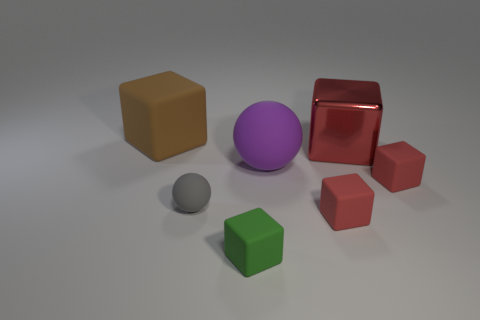Subtract all yellow balls. How many red blocks are left? 3 Subtract 2 cubes. How many cubes are left? 3 Subtract all green cubes. How many cubes are left? 4 Subtract all big shiny blocks. How many blocks are left? 4 Subtract all gray blocks. Subtract all brown balls. How many blocks are left? 5 Add 2 small matte spheres. How many objects exist? 9 Subtract all cubes. How many objects are left? 2 Add 1 red metallic blocks. How many red metallic blocks exist? 2 Subtract 0 red balls. How many objects are left? 7 Subtract all gray rubber blocks. Subtract all small green cubes. How many objects are left? 6 